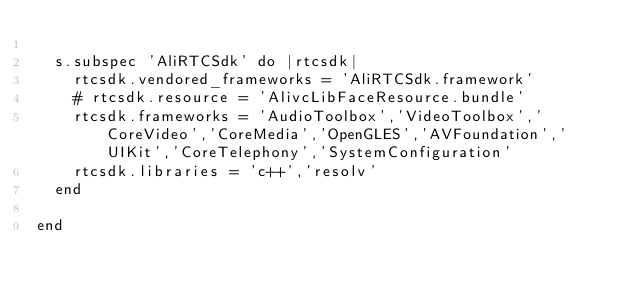<code> <loc_0><loc_0><loc_500><loc_500><_Ruby_>
  s.subspec 'AliRTCSdk' do |rtcsdk|
    rtcsdk.vendored_frameworks = 'AliRTCSdk.framework'
    # rtcsdk.resource = 'AlivcLibFaceResource.bundle'
    rtcsdk.frameworks = 'AudioToolbox','VideoToolbox','CoreVideo','CoreMedia','OpenGLES','AVFoundation','UIKit','CoreTelephony','SystemConfiguration'
    rtcsdk.libraries = 'c++','resolv'
  end

end
</code> 